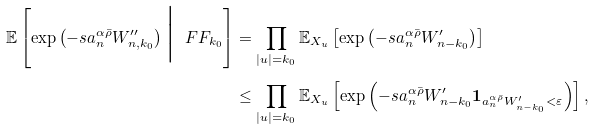Convert formula to latex. <formula><loc_0><loc_0><loc_500><loc_500>\mathbb { E } \left [ \exp \left ( - s a _ { n } ^ { \alpha \bar { \rho } } W _ { n , k _ { 0 } } ^ { \prime \prime } \right ) \Big { | } \ F F _ { k _ { 0 } } \right ] & = \prod _ { | u | = k _ { 0 } } \mathbb { E } _ { X _ { u } } \left [ \exp \left ( - s a _ { n } ^ { \alpha \bar { \rho } } W _ { n - k _ { 0 } } ^ { \prime } \right ) \right ] \\ & \leq \prod _ { | u | = k _ { 0 } } \mathbb { E } _ { X _ { u } } \left [ \exp \left ( - s a _ { n } ^ { \alpha \bar { \rho } } W _ { n - k _ { 0 } } ^ { \prime } \boldsymbol 1 _ { a _ { n } ^ { \alpha \bar { \rho } } W _ { n - k _ { 0 } } ^ { \prime } < \varepsilon } \right ) \right ] ,</formula> 